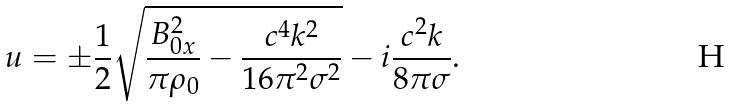<formula> <loc_0><loc_0><loc_500><loc_500>u = \pm \frac { 1 } { 2 } \sqrt { \frac { B _ { 0 x } ^ { 2 } } { \pi \rho _ { 0 } } - \frac { c ^ { 4 } k ^ { 2 } } { 1 6 \pi ^ { 2 } \sigma ^ { 2 } } } - i \frac { c ^ { 2 } k } { 8 \pi \sigma } .</formula> 